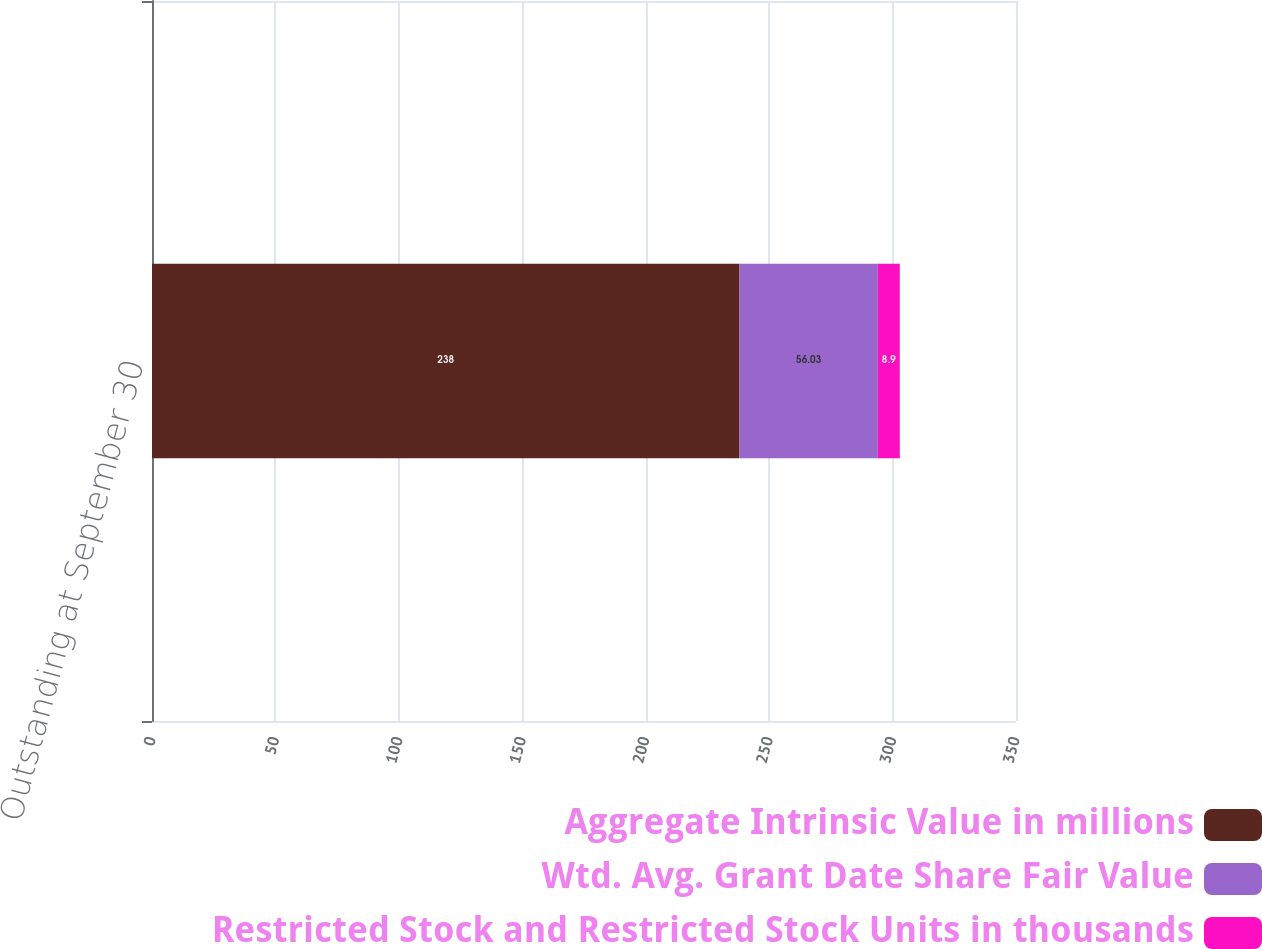Convert chart. <chart><loc_0><loc_0><loc_500><loc_500><stacked_bar_chart><ecel><fcel>Outstanding at September 30<nl><fcel>Aggregate Intrinsic Value in millions<fcel>238<nl><fcel>Wtd. Avg. Grant Date Share Fair Value<fcel>56.03<nl><fcel>Restricted Stock and Restricted Stock Units in thousands<fcel>8.9<nl></chart> 